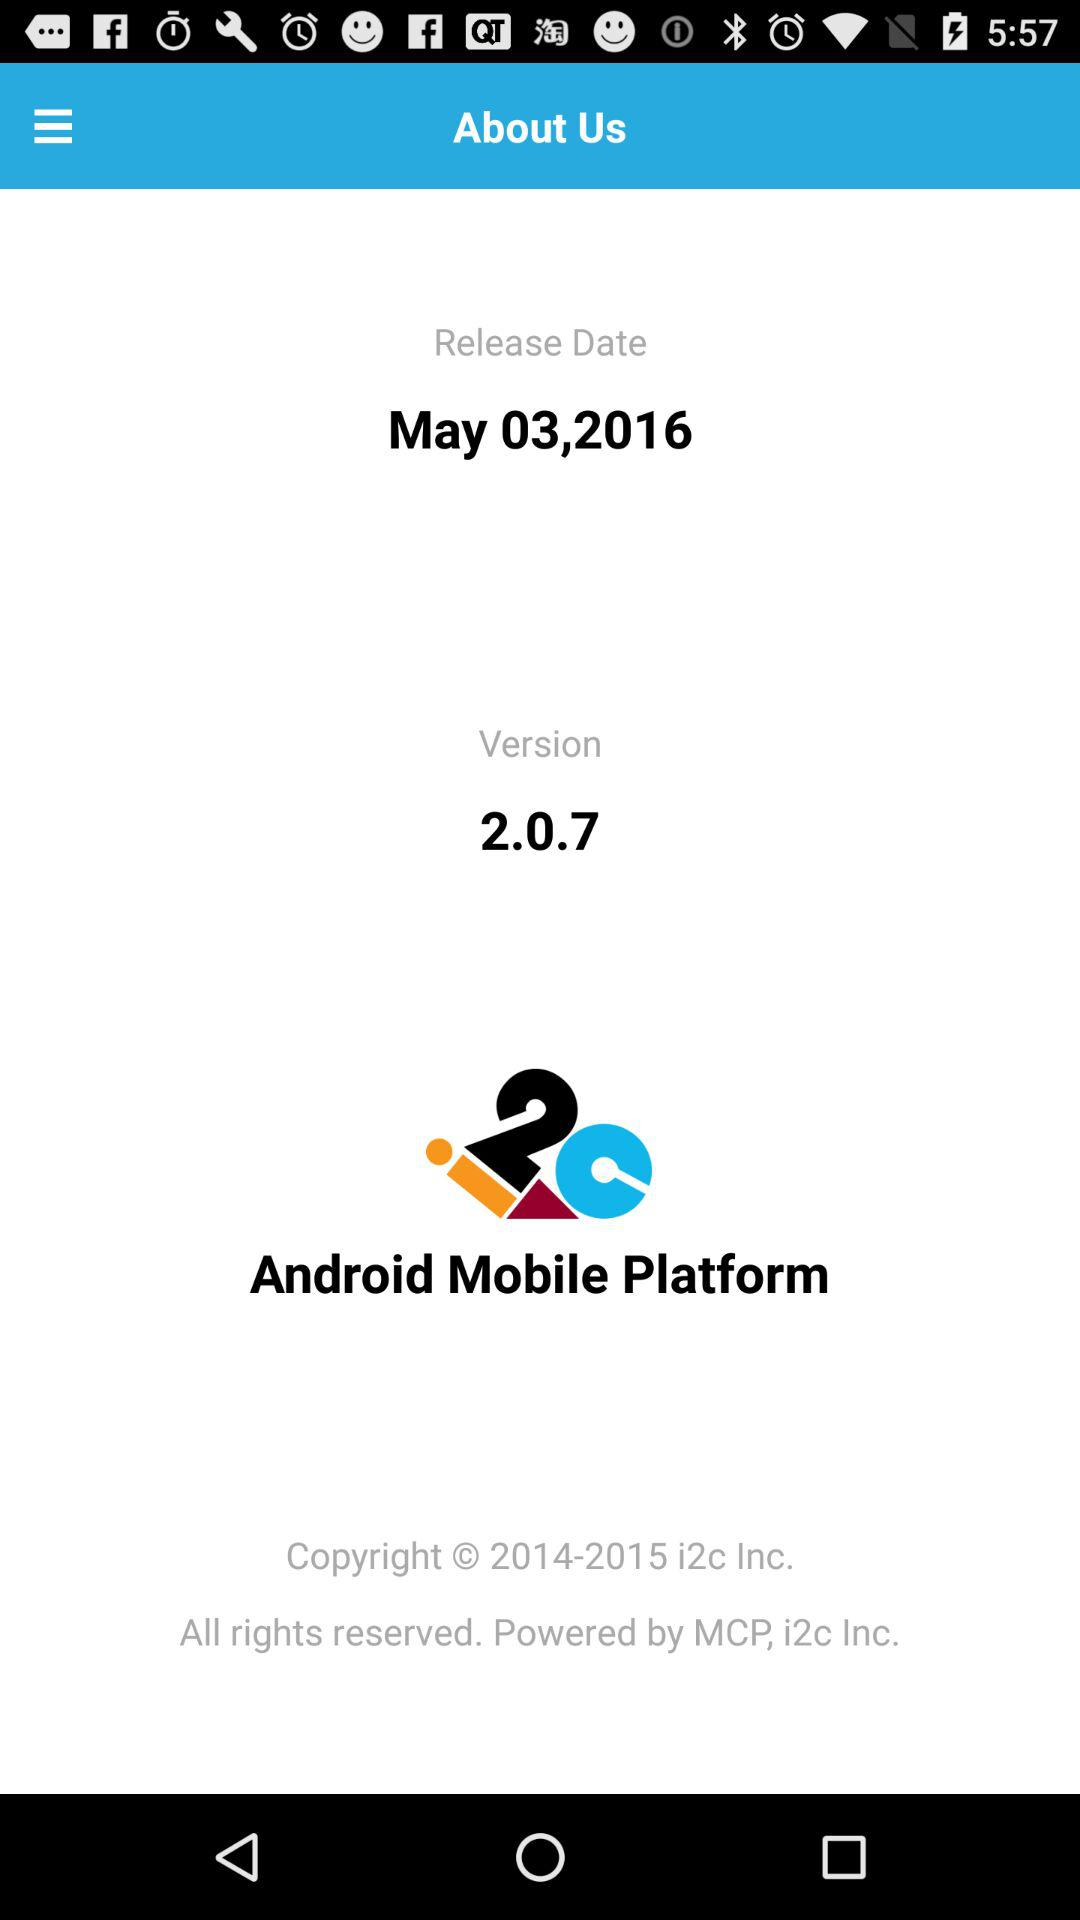What is the version? The version is 2.0.7. 